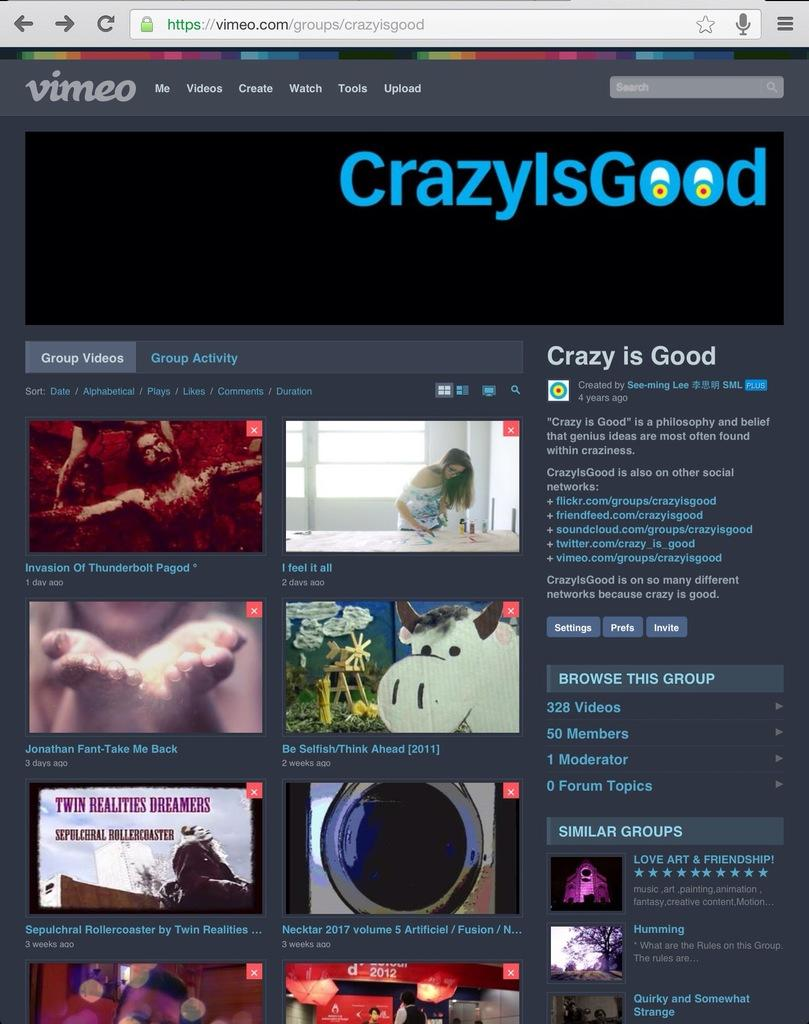<image>
Present a compact description of the photo's key features. Vimeo's main page showing various videos that can be watched. 